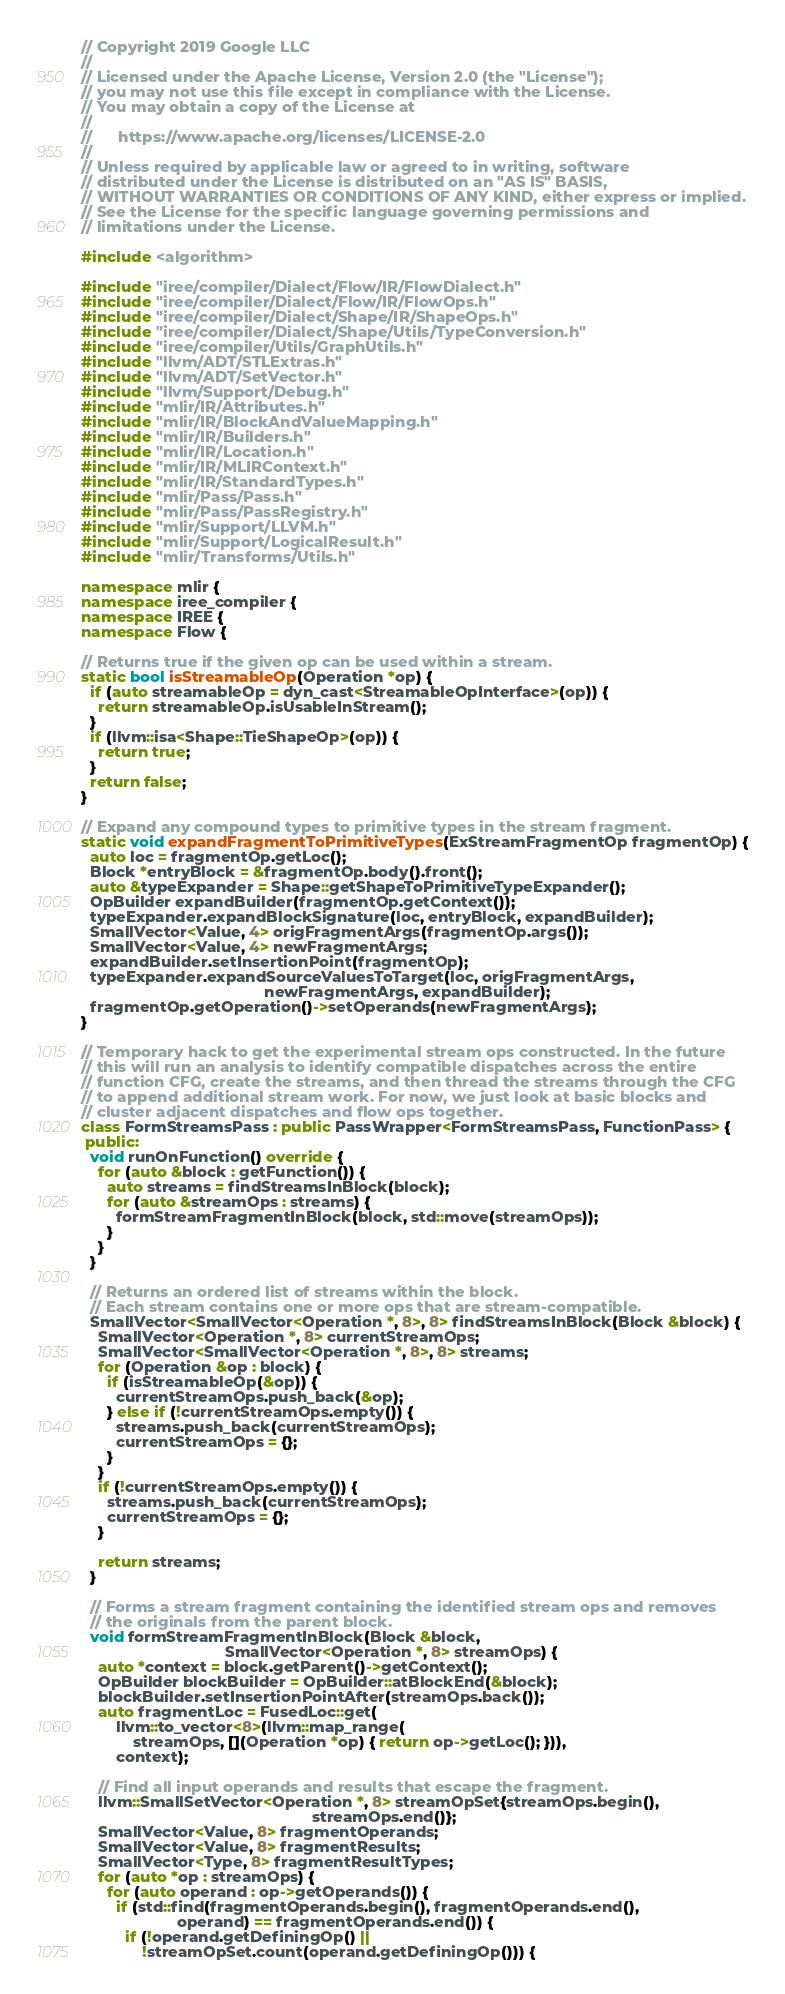<code> <loc_0><loc_0><loc_500><loc_500><_C++_>// Copyright 2019 Google LLC
//
// Licensed under the Apache License, Version 2.0 (the "License");
// you may not use this file except in compliance with the License.
// You may obtain a copy of the License at
//
//      https://www.apache.org/licenses/LICENSE-2.0
//
// Unless required by applicable law or agreed to in writing, software
// distributed under the License is distributed on an "AS IS" BASIS,
// WITHOUT WARRANTIES OR CONDITIONS OF ANY KIND, either express or implied.
// See the License for the specific language governing permissions and
// limitations under the License.

#include <algorithm>

#include "iree/compiler/Dialect/Flow/IR/FlowDialect.h"
#include "iree/compiler/Dialect/Flow/IR/FlowOps.h"
#include "iree/compiler/Dialect/Shape/IR/ShapeOps.h"
#include "iree/compiler/Dialect/Shape/Utils/TypeConversion.h"
#include "iree/compiler/Utils/GraphUtils.h"
#include "llvm/ADT/STLExtras.h"
#include "llvm/ADT/SetVector.h"
#include "llvm/Support/Debug.h"
#include "mlir/IR/Attributes.h"
#include "mlir/IR/BlockAndValueMapping.h"
#include "mlir/IR/Builders.h"
#include "mlir/IR/Location.h"
#include "mlir/IR/MLIRContext.h"
#include "mlir/IR/StandardTypes.h"
#include "mlir/Pass/Pass.h"
#include "mlir/Pass/PassRegistry.h"
#include "mlir/Support/LLVM.h"
#include "mlir/Support/LogicalResult.h"
#include "mlir/Transforms/Utils.h"

namespace mlir {
namespace iree_compiler {
namespace IREE {
namespace Flow {

// Returns true if the given op can be used within a stream.
static bool isStreamableOp(Operation *op) {
  if (auto streamableOp = dyn_cast<StreamableOpInterface>(op)) {
    return streamableOp.isUsableInStream();
  }
  if (llvm::isa<Shape::TieShapeOp>(op)) {
    return true;
  }
  return false;
}

// Expand any compound types to primitive types in the stream fragment.
static void expandFragmentToPrimitiveTypes(ExStreamFragmentOp fragmentOp) {
  auto loc = fragmentOp.getLoc();
  Block *entryBlock = &fragmentOp.body().front();
  auto &typeExpander = Shape::getShapeToPrimitiveTypeExpander();
  OpBuilder expandBuilder(fragmentOp.getContext());
  typeExpander.expandBlockSignature(loc, entryBlock, expandBuilder);
  SmallVector<Value, 4> origFragmentArgs(fragmentOp.args());
  SmallVector<Value, 4> newFragmentArgs;
  expandBuilder.setInsertionPoint(fragmentOp);
  typeExpander.expandSourceValuesToTarget(loc, origFragmentArgs,
                                          newFragmentArgs, expandBuilder);
  fragmentOp.getOperation()->setOperands(newFragmentArgs);
}

// Temporary hack to get the experimental stream ops constructed. In the future
// this will run an analysis to identify compatible dispatches across the entire
// function CFG, create the streams, and then thread the streams through the CFG
// to append additional stream work. For now, we just look at basic blocks and
// cluster adjacent dispatches and flow ops together.
class FormStreamsPass : public PassWrapper<FormStreamsPass, FunctionPass> {
 public:
  void runOnFunction() override {
    for (auto &block : getFunction()) {
      auto streams = findStreamsInBlock(block);
      for (auto &streamOps : streams) {
        formStreamFragmentInBlock(block, std::move(streamOps));
      }
    }
  }

  // Returns an ordered list of streams within the block.
  // Each stream contains one or more ops that are stream-compatible.
  SmallVector<SmallVector<Operation *, 8>, 8> findStreamsInBlock(Block &block) {
    SmallVector<Operation *, 8> currentStreamOps;
    SmallVector<SmallVector<Operation *, 8>, 8> streams;
    for (Operation &op : block) {
      if (isStreamableOp(&op)) {
        currentStreamOps.push_back(&op);
      } else if (!currentStreamOps.empty()) {
        streams.push_back(currentStreamOps);
        currentStreamOps = {};
      }
    }
    if (!currentStreamOps.empty()) {
      streams.push_back(currentStreamOps);
      currentStreamOps = {};
    }

    return streams;
  }

  // Forms a stream fragment containing the identified stream ops and removes
  // the originals from the parent block.
  void formStreamFragmentInBlock(Block &block,
                                 SmallVector<Operation *, 8> streamOps) {
    auto *context = block.getParent()->getContext();
    OpBuilder blockBuilder = OpBuilder::atBlockEnd(&block);
    blockBuilder.setInsertionPointAfter(streamOps.back());
    auto fragmentLoc = FusedLoc::get(
        llvm::to_vector<8>(llvm::map_range(
            streamOps, [](Operation *op) { return op->getLoc(); })),
        context);

    // Find all input operands and results that escape the fragment.
    llvm::SmallSetVector<Operation *, 8> streamOpSet{streamOps.begin(),
                                                     streamOps.end()};
    SmallVector<Value, 8> fragmentOperands;
    SmallVector<Value, 8> fragmentResults;
    SmallVector<Type, 8> fragmentResultTypes;
    for (auto *op : streamOps) {
      for (auto operand : op->getOperands()) {
        if (std::find(fragmentOperands.begin(), fragmentOperands.end(),
                      operand) == fragmentOperands.end()) {
          if (!operand.getDefiningOp() ||
              !streamOpSet.count(operand.getDefiningOp())) {</code> 